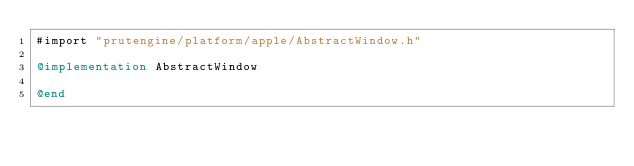Convert code to text. <code><loc_0><loc_0><loc_500><loc_500><_ObjectiveC_>#import "prutengine/platform/apple/AbstractWindow.h"

@implementation AbstractWindow

@end
</code> 